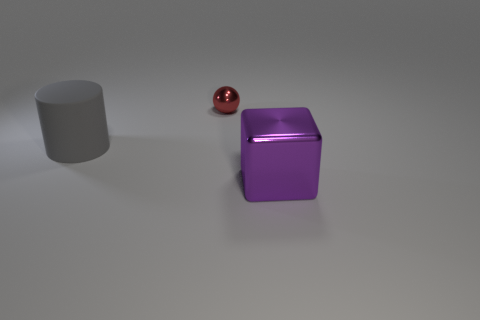The shiny object on the left side of the big block has what shape?
Ensure brevity in your answer.  Sphere. There is a gray rubber object; is it the same size as the shiny thing that is behind the rubber cylinder?
Keep it short and to the point. No. Is there a small sphere made of the same material as the cube?
Your answer should be very brief. Yes. What number of blocks are big yellow rubber things or rubber objects?
Offer a very short reply. 0. There is a shiny object that is in front of the tiny thing; are there any red metal objects that are to the right of it?
Provide a succinct answer. No. Are there fewer large gray rubber cylinders than small brown blocks?
Make the answer very short. No. What number of red objects are cylinders or spheres?
Keep it short and to the point. 1. There is a metallic object that is to the right of the metallic object that is behind the gray object; how big is it?
Ensure brevity in your answer.  Large. What number of yellow matte objects have the same size as the gray matte object?
Your answer should be very brief. 0. Is the purple thing the same size as the cylinder?
Provide a succinct answer. Yes. 